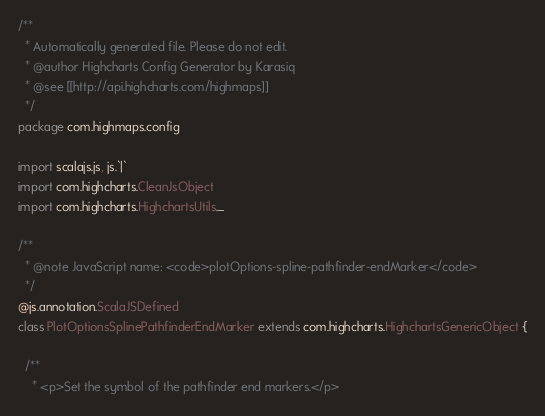<code> <loc_0><loc_0><loc_500><loc_500><_Scala_>/**
  * Automatically generated file. Please do not edit.
  * @author Highcharts Config Generator by Karasiq
  * @see [[http://api.highcharts.com/highmaps]]
  */
package com.highmaps.config

import scalajs.js, js.`|`
import com.highcharts.CleanJsObject
import com.highcharts.HighchartsUtils._

/**
  * @note JavaScript name: <code>plotOptions-spline-pathfinder-endMarker</code>
  */
@js.annotation.ScalaJSDefined
class PlotOptionsSplinePathfinderEndMarker extends com.highcharts.HighchartsGenericObject {

  /**
    * <p>Set the symbol of the pathfinder end markers.</p></code> 